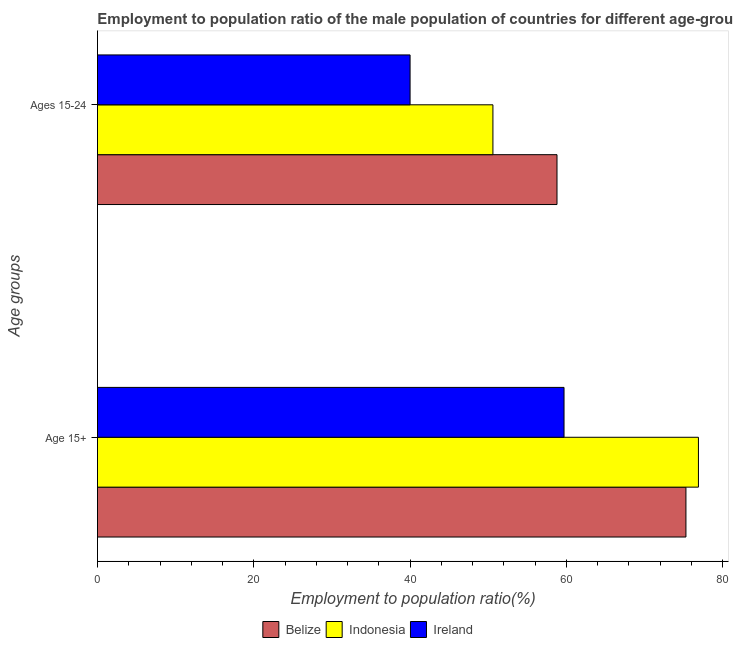How many different coloured bars are there?
Provide a short and direct response. 3. How many groups of bars are there?
Offer a very short reply. 2. Are the number of bars per tick equal to the number of legend labels?
Make the answer very short. Yes. Are the number of bars on each tick of the Y-axis equal?
Offer a terse response. Yes. How many bars are there on the 1st tick from the top?
Your response must be concise. 3. What is the label of the 2nd group of bars from the top?
Offer a terse response. Age 15+. What is the employment to population ratio(age 15-24) in Belize?
Your answer should be compact. 58.8. Across all countries, what is the maximum employment to population ratio(age 15+)?
Ensure brevity in your answer.  76.9. Across all countries, what is the minimum employment to population ratio(age 15-24)?
Provide a succinct answer. 40. In which country was the employment to population ratio(age 15-24) maximum?
Provide a succinct answer. Belize. In which country was the employment to population ratio(age 15-24) minimum?
Your answer should be very brief. Ireland. What is the total employment to population ratio(age 15+) in the graph?
Make the answer very short. 211.9. What is the difference between the employment to population ratio(age 15+) in Belize and that in Indonesia?
Offer a terse response. -1.6. What is the difference between the employment to population ratio(age 15-24) in Ireland and the employment to population ratio(age 15+) in Indonesia?
Your response must be concise. -36.9. What is the average employment to population ratio(age 15+) per country?
Your response must be concise. 70.63. What is the difference between the employment to population ratio(age 15-24) and employment to population ratio(age 15+) in Ireland?
Offer a very short reply. -19.7. What is the ratio of the employment to population ratio(age 15+) in Ireland to that in Indonesia?
Your answer should be compact. 0.78. In how many countries, is the employment to population ratio(age 15+) greater than the average employment to population ratio(age 15+) taken over all countries?
Offer a terse response. 2. What does the 3rd bar from the top in Age 15+ represents?
Give a very brief answer. Belize. What does the 2nd bar from the bottom in Age 15+ represents?
Your answer should be very brief. Indonesia. How many bars are there?
Your answer should be compact. 6. Are all the bars in the graph horizontal?
Offer a terse response. Yes. Are the values on the major ticks of X-axis written in scientific E-notation?
Your response must be concise. No. Does the graph contain any zero values?
Make the answer very short. No. Does the graph contain grids?
Your response must be concise. No. How are the legend labels stacked?
Keep it short and to the point. Horizontal. What is the title of the graph?
Offer a terse response. Employment to population ratio of the male population of countries for different age-groups. What is the label or title of the Y-axis?
Ensure brevity in your answer.  Age groups. What is the Employment to population ratio(%) in Belize in Age 15+?
Your answer should be compact. 75.3. What is the Employment to population ratio(%) in Indonesia in Age 15+?
Your answer should be very brief. 76.9. What is the Employment to population ratio(%) of Ireland in Age 15+?
Your answer should be compact. 59.7. What is the Employment to population ratio(%) of Belize in Ages 15-24?
Provide a short and direct response. 58.8. What is the Employment to population ratio(%) in Indonesia in Ages 15-24?
Your answer should be very brief. 50.6. What is the Employment to population ratio(%) of Ireland in Ages 15-24?
Offer a terse response. 40. Across all Age groups, what is the maximum Employment to population ratio(%) of Belize?
Your answer should be compact. 75.3. Across all Age groups, what is the maximum Employment to population ratio(%) of Indonesia?
Provide a succinct answer. 76.9. Across all Age groups, what is the maximum Employment to population ratio(%) of Ireland?
Make the answer very short. 59.7. Across all Age groups, what is the minimum Employment to population ratio(%) of Belize?
Provide a succinct answer. 58.8. Across all Age groups, what is the minimum Employment to population ratio(%) in Indonesia?
Provide a short and direct response. 50.6. Across all Age groups, what is the minimum Employment to population ratio(%) of Ireland?
Provide a short and direct response. 40. What is the total Employment to population ratio(%) in Belize in the graph?
Offer a very short reply. 134.1. What is the total Employment to population ratio(%) in Indonesia in the graph?
Your response must be concise. 127.5. What is the total Employment to population ratio(%) in Ireland in the graph?
Your response must be concise. 99.7. What is the difference between the Employment to population ratio(%) of Indonesia in Age 15+ and that in Ages 15-24?
Offer a very short reply. 26.3. What is the difference between the Employment to population ratio(%) in Belize in Age 15+ and the Employment to population ratio(%) in Indonesia in Ages 15-24?
Provide a short and direct response. 24.7. What is the difference between the Employment to population ratio(%) of Belize in Age 15+ and the Employment to population ratio(%) of Ireland in Ages 15-24?
Provide a short and direct response. 35.3. What is the difference between the Employment to population ratio(%) of Indonesia in Age 15+ and the Employment to population ratio(%) of Ireland in Ages 15-24?
Provide a short and direct response. 36.9. What is the average Employment to population ratio(%) of Belize per Age groups?
Keep it short and to the point. 67.05. What is the average Employment to population ratio(%) of Indonesia per Age groups?
Offer a very short reply. 63.75. What is the average Employment to population ratio(%) in Ireland per Age groups?
Make the answer very short. 49.85. What is the difference between the Employment to population ratio(%) in Belize and Employment to population ratio(%) in Ireland in Age 15+?
Your answer should be compact. 15.6. What is the difference between the Employment to population ratio(%) of Indonesia and Employment to population ratio(%) of Ireland in Age 15+?
Offer a very short reply. 17.2. What is the difference between the Employment to population ratio(%) of Belize and Employment to population ratio(%) of Ireland in Ages 15-24?
Offer a terse response. 18.8. What is the difference between the Employment to population ratio(%) of Indonesia and Employment to population ratio(%) of Ireland in Ages 15-24?
Offer a very short reply. 10.6. What is the ratio of the Employment to population ratio(%) in Belize in Age 15+ to that in Ages 15-24?
Your response must be concise. 1.28. What is the ratio of the Employment to population ratio(%) of Indonesia in Age 15+ to that in Ages 15-24?
Your answer should be very brief. 1.52. What is the ratio of the Employment to population ratio(%) in Ireland in Age 15+ to that in Ages 15-24?
Your answer should be compact. 1.49. What is the difference between the highest and the second highest Employment to population ratio(%) of Belize?
Offer a very short reply. 16.5. What is the difference between the highest and the second highest Employment to population ratio(%) of Indonesia?
Ensure brevity in your answer.  26.3. What is the difference between the highest and the lowest Employment to population ratio(%) of Indonesia?
Provide a short and direct response. 26.3. What is the difference between the highest and the lowest Employment to population ratio(%) of Ireland?
Your answer should be very brief. 19.7. 